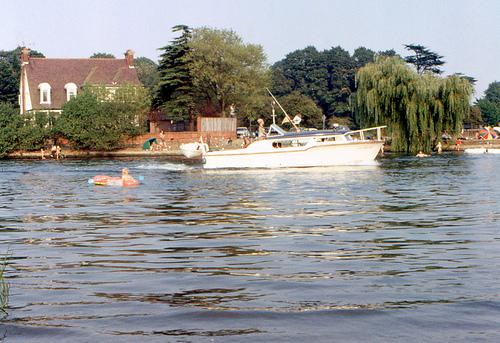Question: what kind of vehicle is in the photo?
Choices:
A. Airplane.
B. Boat.
C. Car.
D. Bus.
Answer with the letter. Answer: B Question: what are the structures in the background of the photo?
Choices:
A. Factories.
B. Houses.
C. Garages.
D. Apartments.
Answer with the letter. Answer: B Question: where is the boat?
Choices:
A. Dock.
B. Factory.
C. Harbor.
D. Body of water.
Answer with the letter. Answer: D 